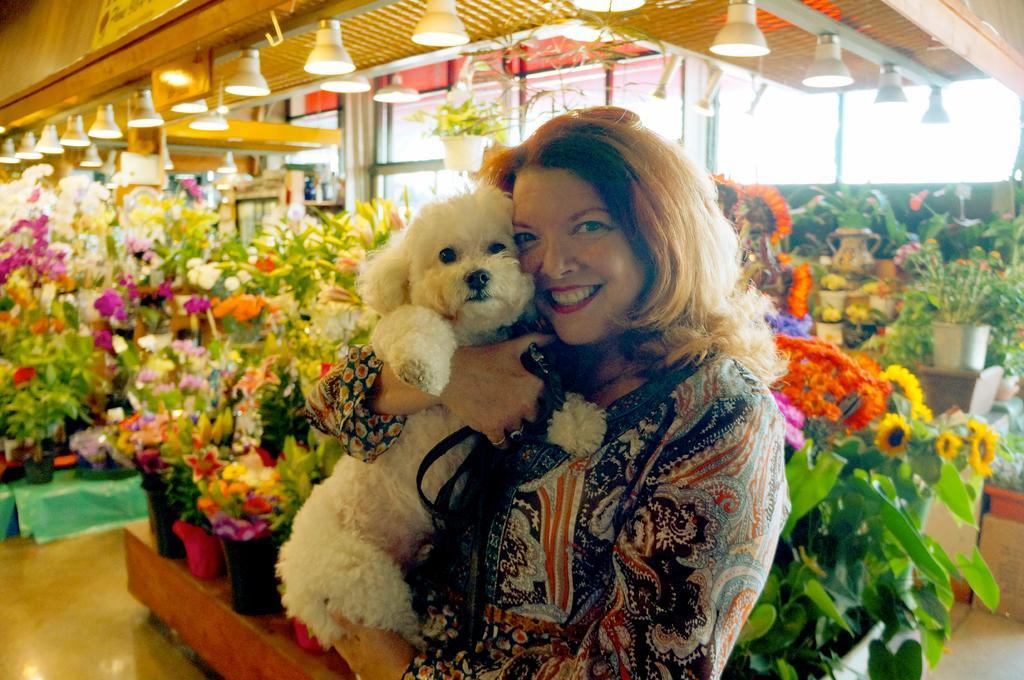Could you give a brief overview of what you see in this image? In this image in the front there is a woman standing and smiling and holding a dog in her hand. In the background there are plants and there are flowers and on the top there lights hanging there are windows. 